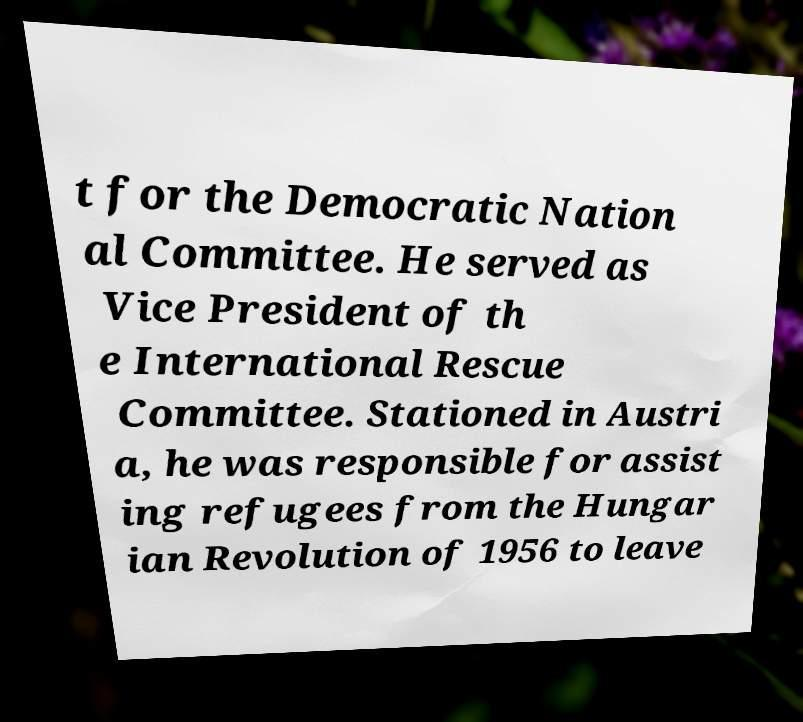I need the written content from this picture converted into text. Can you do that? t for the Democratic Nation al Committee. He served as Vice President of th e International Rescue Committee. Stationed in Austri a, he was responsible for assist ing refugees from the Hungar ian Revolution of 1956 to leave 